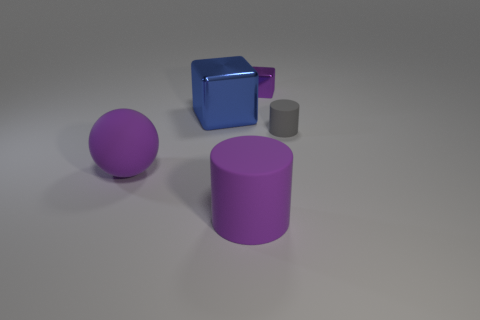Are there fewer purple matte spheres than small blue metallic objects?
Provide a succinct answer. No. What material is the purple ball that is the same size as the blue shiny object?
Your answer should be compact. Rubber. How many objects are either small brown rubber balls or small cylinders?
Offer a terse response. 1. How many matte objects are both on the left side of the small purple metal thing and to the right of the sphere?
Offer a terse response. 1. Is the number of things that are to the right of the gray rubber cylinder less than the number of blue shiny balls?
Keep it short and to the point. No. There is a gray matte object that is the same size as the purple block; what shape is it?
Offer a terse response. Cylinder. What number of other things are the same color as the sphere?
Give a very brief answer. 2. Does the purple ball have the same size as the purple matte cylinder?
Your answer should be compact. Yes. How many objects are large purple cylinders or metal things that are to the right of the large blue metallic cube?
Provide a succinct answer. 2. Is the number of small gray rubber objects that are to the left of the big purple cylinder less than the number of purple objects in front of the big blue metallic cube?
Ensure brevity in your answer.  Yes. 